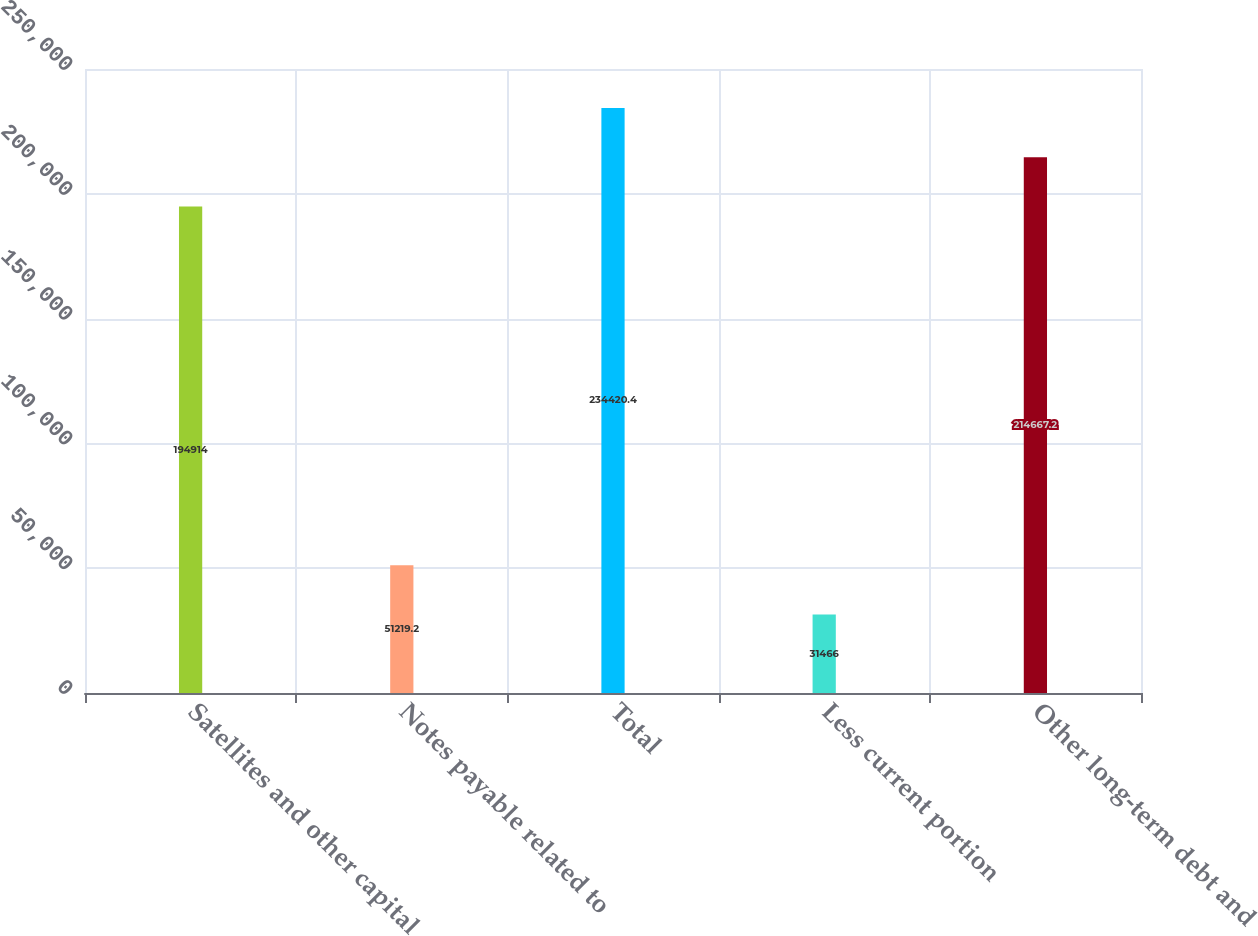Convert chart to OTSL. <chart><loc_0><loc_0><loc_500><loc_500><bar_chart><fcel>Satellites and other capital<fcel>Notes payable related to<fcel>Total<fcel>Less current portion<fcel>Other long-term debt and<nl><fcel>194914<fcel>51219.2<fcel>234420<fcel>31466<fcel>214667<nl></chart> 